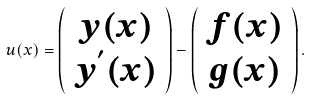Convert formula to latex. <formula><loc_0><loc_0><loc_500><loc_500>u ( x ) = \left ( \begin{array} { c } y ( x ) \\ y ^ { ^ { \prime } } ( x ) \\ \end{array} \right ) - \left ( \begin{array} { c } f ( x ) \\ g ( x ) \\ \end{array} \right ) .</formula> 